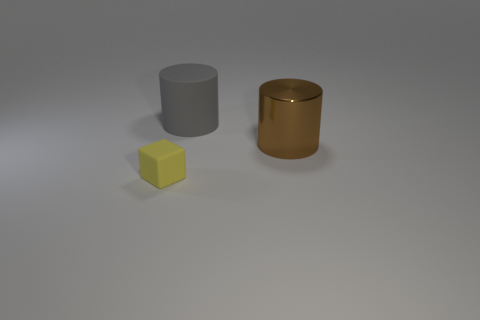Add 3 blue shiny objects. How many objects exist? 6 Subtract all cylinders. How many objects are left? 1 Subtract all large gray matte balls. Subtract all brown metallic cylinders. How many objects are left? 2 Add 1 tiny blocks. How many tiny blocks are left? 2 Add 2 tiny red metallic objects. How many tiny red metallic objects exist? 2 Subtract 0 green cylinders. How many objects are left? 3 